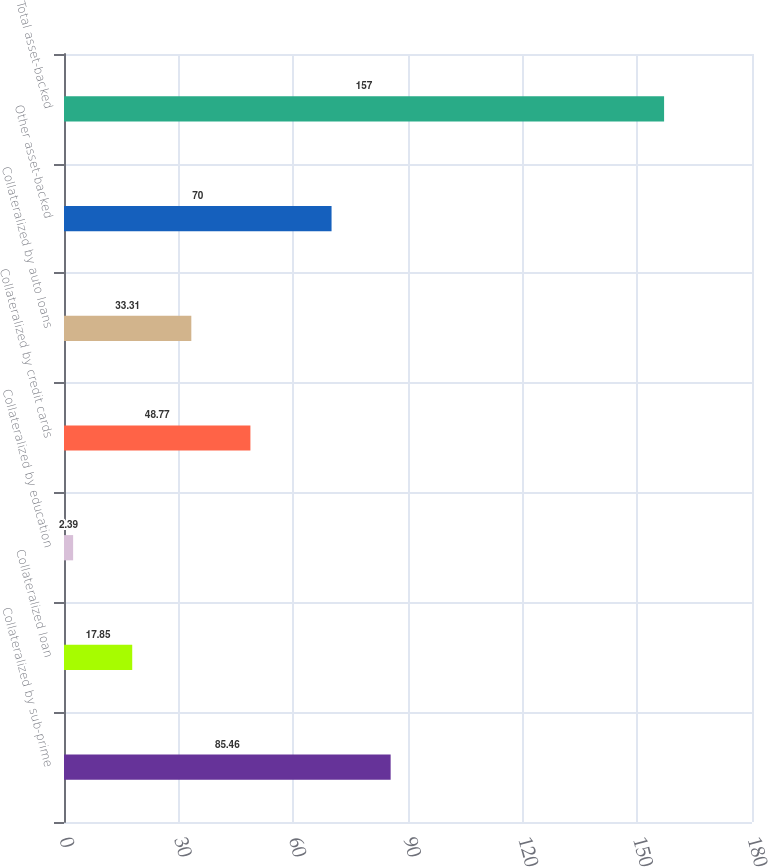Convert chart to OTSL. <chart><loc_0><loc_0><loc_500><loc_500><bar_chart><fcel>Collateralized by sub-prime<fcel>Collateralized loan<fcel>Collateralized by education<fcel>Collateralized by credit cards<fcel>Collateralized by auto loans<fcel>Other asset-backed<fcel>Total asset-backed<nl><fcel>85.46<fcel>17.85<fcel>2.39<fcel>48.77<fcel>33.31<fcel>70<fcel>157<nl></chart> 